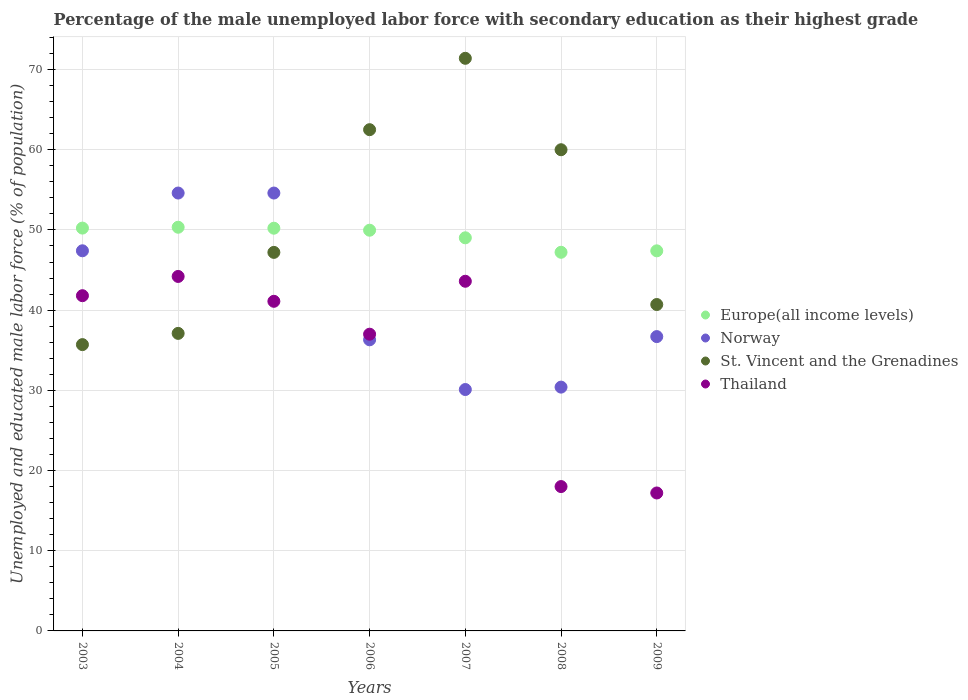What is the percentage of the unemployed male labor force with secondary education in St. Vincent and the Grenadines in 2009?
Make the answer very short. 40.7. Across all years, what is the maximum percentage of the unemployed male labor force with secondary education in Norway?
Your answer should be very brief. 54.6. Across all years, what is the minimum percentage of the unemployed male labor force with secondary education in Europe(all income levels)?
Provide a short and direct response. 47.21. In which year was the percentage of the unemployed male labor force with secondary education in Europe(all income levels) maximum?
Your answer should be very brief. 2004. What is the total percentage of the unemployed male labor force with secondary education in Thailand in the graph?
Offer a terse response. 242.9. What is the difference between the percentage of the unemployed male labor force with secondary education in Europe(all income levels) in 2007 and that in 2009?
Provide a short and direct response. 1.62. What is the difference between the percentage of the unemployed male labor force with secondary education in Europe(all income levels) in 2006 and the percentage of the unemployed male labor force with secondary education in Norway in 2005?
Your answer should be very brief. -4.63. What is the average percentage of the unemployed male labor force with secondary education in Norway per year?
Offer a terse response. 41.44. In the year 2003, what is the difference between the percentage of the unemployed male labor force with secondary education in Norway and percentage of the unemployed male labor force with secondary education in St. Vincent and the Grenadines?
Ensure brevity in your answer.  11.7. In how many years, is the percentage of the unemployed male labor force with secondary education in Europe(all income levels) greater than 34 %?
Provide a succinct answer. 7. What is the ratio of the percentage of the unemployed male labor force with secondary education in Europe(all income levels) in 2003 to that in 2004?
Provide a succinct answer. 1. Is the percentage of the unemployed male labor force with secondary education in Europe(all income levels) in 2003 less than that in 2009?
Offer a very short reply. No. Is the difference between the percentage of the unemployed male labor force with secondary education in Norway in 2007 and 2009 greater than the difference between the percentage of the unemployed male labor force with secondary education in St. Vincent and the Grenadines in 2007 and 2009?
Your response must be concise. No. What is the difference between the highest and the second highest percentage of the unemployed male labor force with secondary education in St. Vincent and the Grenadines?
Your response must be concise. 8.9. What is the difference between the highest and the lowest percentage of the unemployed male labor force with secondary education in St. Vincent and the Grenadines?
Make the answer very short. 35.7. Is it the case that in every year, the sum of the percentage of the unemployed male labor force with secondary education in Norway and percentage of the unemployed male labor force with secondary education in Europe(all income levels)  is greater than the sum of percentage of the unemployed male labor force with secondary education in Thailand and percentage of the unemployed male labor force with secondary education in St. Vincent and the Grenadines?
Offer a very short reply. No. Is it the case that in every year, the sum of the percentage of the unemployed male labor force with secondary education in Norway and percentage of the unemployed male labor force with secondary education in Thailand  is greater than the percentage of the unemployed male labor force with secondary education in Europe(all income levels)?
Ensure brevity in your answer.  Yes. Does the percentage of the unemployed male labor force with secondary education in Europe(all income levels) monotonically increase over the years?
Keep it short and to the point. No. Does the graph contain any zero values?
Give a very brief answer. No. Does the graph contain grids?
Your answer should be very brief. Yes. What is the title of the graph?
Offer a very short reply. Percentage of the male unemployed labor force with secondary education as their highest grade. What is the label or title of the X-axis?
Give a very brief answer. Years. What is the label or title of the Y-axis?
Offer a terse response. Unemployed and educated male labor force (% of population). What is the Unemployed and educated male labor force (% of population) of Europe(all income levels) in 2003?
Your answer should be very brief. 50.23. What is the Unemployed and educated male labor force (% of population) of Norway in 2003?
Your answer should be compact. 47.4. What is the Unemployed and educated male labor force (% of population) in St. Vincent and the Grenadines in 2003?
Make the answer very short. 35.7. What is the Unemployed and educated male labor force (% of population) in Thailand in 2003?
Keep it short and to the point. 41.8. What is the Unemployed and educated male labor force (% of population) of Europe(all income levels) in 2004?
Offer a very short reply. 50.34. What is the Unemployed and educated male labor force (% of population) in Norway in 2004?
Ensure brevity in your answer.  54.6. What is the Unemployed and educated male labor force (% of population) in St. Vincent and the Grenadines in 2004?
Give a very brief answer. 37.1. What is the Unemployed and educated male labor force (% of population) of Thailand in 2004?
Your answer should be compact. 44.2. What is the Unemployed and educated male labor force (% of population) in Europe(all income levels) in 2005?
Give a very brief answer. 50.22. What is the Unemployed and educated male labor force (% of population) in Norway in 2005?
Give a very brief answer. 54.6. What is the Unemployed and educated male labor force (% of population) in St. Vincent and the Grenadines in 2005?
Your answer should be very brief. 47.2. What is the Unemployed and educated male labor force (% of population) in Thailand in 2005?
Your answer should be very brief. 41.1. What is the Unemployed and educated male labor force (% of population) of Europe(all income levels) in 2006?
Give a very brief answer. 49.97. What is the Unemployed and educated male labor force (% of population) in Norway in 2006?
Offer a terse response. 36.3. What is the Unemployed and educated male labor force (% of population) of St. Vincent and the Grenadines in 2006?
Ensure brevity in your answer.  62.5. What is the Unemployed and educated male labor force (% of population) of Europe(all income levels) in 2007?
Provide a short and direct response. 49.02. What is the Unemployed and educated male labor force (% of population) in Norway in 2007?
Offer a very short reply. 30.1. What is the Unemployed and educated male labor force (% of population) in St. Vincent and the Grenadines in 2007?
Provide a short and direct response. 71.4. What is the Unemployed and educated male labor force (% of population) in Thailand in 2007?
Your answer should be compact. 43.6. What is the Unemployed and educated male labor force (% of population) of Europe(all income levels) in 2008?
Offer a very short reply. 47.21. What is the Unemployed and educated male labor force (% of population) of Norway in 2008?
Ensure brevity in your answer.  30.4. What is the Unemployed and educated male labor force (% of population) in Thailand in 2008?
Provide a succinct answer. 18. What is the Unemployed and educated male labor force (% of population) in Europe(all income levels) in 2009?
Your response must be concise. 47.39. What is the Unemployed and educated male labor force (% of population) in Norway in 2009?
Give a very brief answer. 36.7. What is the Unemployed and educated male labor force (% of population) in St. Vincent and the Grenadines in 2009?
Keep it short and to the point. 40.7. What is the Unemployed and educated male labor force (% of population) of Thailand in 2009?
Your response must be concise. 17.2. Across all years, what is the maximum Unemployed and educated male labor force (% of population) of Europe(all income levels)?
Your answer should be very brief. 50.34. Across all years, what is the maximum Unemployed and educated male labor force (% of population) in Norway?
Make the answer very short. 54.6. Across all years, what is the maximum Unemployed and educated male labor force (% of population) in St. Vincent and the Grenadines?
Offer a terse response. 71.4. Across all years, what is the maximum Unemployed and educated male labor force (% of population) in Thailand?
Provide a succinct answer. 44.2. Across all years, what is the minimum Unemployed and educated male labor force (% of population) of Europe(all income levels)?
Offer a very short reply. 47.21. Across all years, what is the minimum Unemployed and educated male labor force (% of population) of Norway?
Offer a terse response. 30.1. Across all years, what is the minimum Unemployed and educated male labor force (% of population) of St. Vincent and the Grenadines?
Your response must be concise. 35.7. Across all years, what is the minimum Unemployed and educated male labor force (% of population) of Thailand?
Offer a terse response. 17.2. What is the total Unemployed and educated male labor force (% of population) in Europe(all income levels) in the graph?
Your response must be concise. 344.37. What is the total Unemployed and educated male labor force (% of population) of Norway in the graph?
Provide a short and direct response. 290.1. What is the total Unemployed and educated male labor force (% of population) of St. Vincent and the Grenadines in the graph?
Give a very brief answer. 354.6. What is the total Unemployed and educated male labor force (% of population) of Thailand in the graph?
Provide a short and direct response. 242.9. What is the difference between the Unemployed and educated male labor force (% of population) of Europe(all income levels) in 2003 and that in 2004?
Offer a very short reply. -0.11. What is the difference between the Unemployed and educated male labor force (% of population) of St. Vincent and the Grenadines in 2003 and that in 2004?
Offer a terse response. -1.4. What is the difference between the Unemployed and educated male labor force (% of population) in Europe(all income levels) in 2003 and that in 2005?
Give a very brief answer. 0.01. What is the difference between the Unemployed and educated male labor force (% of population) of St. Vincent and the Grenadines in 2003 and that in 2005?
Make the answer very short. -11.5. What is the difference between the Unemployed and educated male labor force (% of population) in Europe(all income levels) in 2003 and that in 2006?
Your answer should be very brief. 0.26. What is the difference between the Unemployed and educated male labor force (% of population) of Norway in 2003 and that in 2006?
Ensure brevity in your answer.  11.1. What is the difference between the Unemployed and educated male labor force (% of population) of St. Vincent and the Grenadines in 2003 and that in 2006?
Offer a terse response. -26.8. What is the difference between the Unemployed and educated male labor force (% of population) of Europe(all income levels) in 2003 and that in 2007?
Your answer should be compact. 1.21. What is the difference between the Unemployed and educated male labor force (% of population) in St. Vincent and the Grenadines in 2003 and that in 2007?
Give a very brief answer. -35.7. What is the difference between the Unemployed and educated male labor force (% of population) in Thailand in 2003 and that in 2007?
Keep it short and to the point. -1.8. What is the difference between the Unemployed and educated male labor force (% of population) in Europe(all income levels) in 2003 and that in 2008?
Ensure brevity in your answer.  3.02. What is the difference between the Unemployed and educated male labor force (% of population) in Norway in 2003 and that in 2008?
Offer a terse response. 17. What is the difference between the Unemployed and educated male labor force (% of population) in St. Vincent and the Grenadines in 2003 and that in 2008?
Make the answer very short. -24.3. What is the difference between the Unemployed and educated male labor force (% of population) of Thailand in 2003 and that in 2008?
Your answer should be very brief. 23.8. What is the difference between the Unemployed and educated male labor force (% of population) in Europe(all income levels) in 2003 and that in 2009?
Provide a short and direct response. 2.84. What is the difference between the Unemployed and educated male labor force (% of population) in St. Vincent and the Grenadines in 2003 and that in 2009?
Ensure brevity in your answer.  -5. What is the difference between the Unemployed and educated male labor force (% of population) of Thailand in 2003 and that in 2009?
Make the answer very short. 24.6. What is the difference between the Unemployed and educated male labor force (% of population) in Europe(all income levels) in 2004 and that in 2005?
Keep it short and to the point. 0.12. What is the difference between the Unemployed and educated male labor force (% of population) in St. Vincent and the Grenadines in 2004 and that in 2005?
Make the answer very short. -10.1. What is the difference between the Unemployed and educated male labor force (% of population) of Thailand in 2004 and that in 2005?
Make the answer very short. 3.1. What is the difference between the Unemployed and educated male labor force (% of population) in Europe(all income levels) in 2004 and that in 2006?
Offer a very short reply. 0.37. What is the difference between the Unemployed and educated male labor force (% of population) in Norway in 2004 and that in 2006?
Provide a short and direct response. 18.3. What is the difference between the Unemployed and educated male labor force (% of population) in St. Vincent and the Grenadines in 2004 and that in 2006?
Provide a succinct answer. -25.4. What is the difference between the Unemployed and educated male labor force (% of population) in Thailand in 2004 and that in 2006?
Provide a short and direct response. 7.2. What is the difference between the Unemployed and educated male labor force (% of population) of Europe(all income levels) in 2004 and that in 2007?
Give a very brief answer. 1.32. What is the difference between the Unemployed and educated male labor force (% of population) in St. Vincent and the Grenadines in 2004 and that in 2007?
Your answer should be very brief. -34.3. What is the difference between the Unemployed and educated male labor force (% of population) of Thailand in 2004 and that in 2007?
Offer a very short reply. 0.6. What is the difference between the Unemployed and educated male labor force (% of population) in Europe(all income levels) in 2004 and that in 2008?
Offer a very short reply. 3.12. What is the difference between the Unemployed and educated male labor force (% of population) in Norway in 2004 and that in 2008?
Make the answer very short. 24.2. What is the difference between the Unemployed and educated male labor force (% of population) of St. Vincent and the Grenadines in 2004 and that in 2008?
Provide a succinct answer. -22.9. What is the difference between the Unemployed and educated male labor force (% of population) of Thailand in 2004 and that in 2008?
Offer a terse response. 26.2. What is the difference between the Unemployed and educated male labor force (% of population) in Europe(all income levels) in 2004 and that in 2009?
Your answer should be compact. 2.94. What is the difference between the Unemployed and educated male labor force (% of population) of Norway in 2004 and that in 2009?
Ensure brevity in your answer.  17.9. What is the difference between the Unemployed and educated male labor force (% of population) of Europe(all income levels) in 2005 and that in 2006?
Your answer should be very brief. 0.25. What is the difference between the Unemployed and educated male labor force (% of population) in Norway in 2005 and that in 2006?
Your answer should be compact. 18.3. What is the difference between the Unemployed and educated male labor force (% of population) of St. Vincent and the Grenadines in 2005 and that in 2006?
Offer a very short reply. -15.3. What is the difference between the Unemployed and educated male labor force (% of population) in Europe(all income levels) in 2005 and that in 2007?
Your answer should be very brief. 1.2. What is the difference between the Unemployed and educated male labor force (% of population) in Norway in 2005 and that in 2007?
Provide a short and direct response. 24.5. What is the difference between the Unemployed and educated male labor force (% of population) in St. Vincent and the Grenadines in 2005 and that in 2007?
Your answer should be compact. -24.2. What is the difference between the Unemployed and educated male labor force (% of population) of Thailand in 2005 and that in 2007?
Your response must be concise. -2.5. What is the difference between the Unemployed and educated male labor force (% of population) of Europe(all income levels) in 2005 and that in 2008?
Keep it short and to the point. 3. What is the difference between the Unemployed and educated male labor force (% of population) in Norway in 2005 and that in 2008?
Give a very brief answer. 24.2. What is the difference between the Unemployed and educated male labor force (% of population) of St. Vincent and the Grenadines in 2005 and that in 2008?
Keep it short and to the point. -12.8. What is the difference between the Unemployed and educated male labor force (% of population) in Thailand in 2005 and that in 2008?
Your answer should be very brief. 23.1. What is the difference between the Unemployed and educated male labor force (% of population) of Europe(all income levels) in 2005 and that in 2009?
Ensure brevity in your answer.  2.82. What is the difference between the Unemployed and educated male labor force (% of population) of Thailand in 2005 and that in 2009?
Give a very brief answer. 23.9. What is the difference between the Unemployed and educated male labor force (% of population) of Europe(all income levels) in 2006 and that in 2007?
Provide a short and direct response. 0.95. What is the difference between the Unemployed and educated male labor force (% of population) in Europe(all income levels) in 2006 and that in 2008?
Your response must be concise. 2.75. What is the difference between the Unemployed and educated male labor force (% of population) of Norway in 2006 and that in 2008?
Offer a terse response. 5.9. What is the difference between the Unemployed and educated male labor force (% of population) in St. Vincent and the Grenadines in 2006 and that in 2008?
Your response must be concise. 2.5. What is the difference between the Unemployed and educated male labor force (% of population) in Thailand in 2006 and that in 2008?
Give a very brief answer. 19. What is the difference between the Unemployed and educated male labor force (% of population) of Europe(all income levels) in 2006 and that in 2009?
Your response must be concise. 2.57. What is the difference between the Unemployed and educated male labor force (% of population) of Norway in 2006 and that in 2009?
Ensure brevity in your answer.  -0.4. What is the difference between the Unemployed and educated male labor force (% of population) in St. Vincent and the Grenadines in 2006 and that in 2009?
Your answer should be very brief. 21.8. What is the difference between the Unemployed and educated male labor force (% of population) in Thailand in 2006 and that in 2009?
Provide a succinct answer. 19.8. What is the difference between the Unemployed and educated male labor force (% of population) in Europe(all income levels) in 2007 and that in 2008?
Your answer should be very brief. 1.8. What is the difference between the Unemployed and educated male labor force (% of population) of Thailand in 2007 and that in 2008?
Your response must be concise. 25.6. What is the difference between the Unemployed and educated male labor force (% of population) of Europe(all income levels) in 2007 and that in 2009?
Offer a terse response. 1.62. What is the difference between the Unemployed and educated male labor force (% of population) in St. Vincent and the Grenadines in 2007 and that in 2009?
Offer a very short reply. 30.7. What is the difference between the Unemployed and educated male labor force (% of population) of Thailand in 2007 and that in 2009?
Offer a terse response. 26.4. What is the difference between the Unemployed and educated male labor force (% of population) of Europe(all income levels) in 2008 and that in 2009?
Make the answer very short. -0.18. What is the difference between the Unemployed and educated male labor force (% of population) in Norway in 2008 and that in 2009?
Offer a terse response. -6.3. What is the difference between the Unemployed and educated male labor force (% of population) of St. Vincent and the Grenadines in 2008 and that in 2009?
Your answer should be very brief. 19.3. What is the difference between the Unemployed and educated male labor force (% of population) in Europe(all income levels) in 2003 and the Unemployed and educated male labor force (% of population) in Norway in 2004?
Ensure brevity in your answer.  -4.37. What is the difference between the Unemployed and educated male labor force (% of population) in Europe(all income levels) in 2003 and the Unemployed and educated male labor force (% of population) in St. Vincent and the Grenadines in 2004?
Make the answer very short. 13.13. What is the difference between the Unemployed and educated male labor force (% of population) in Europe(all income levels) in 2003 and the Unemployed and educated male labor force (% of population) in Thailand in 2004?
Make the answer very short. 6.03. What is the difference between the Unemployed and educated male labor force (% of population) of Europe(all income levels) in 2003 and the Unemployed and educated male labor force (% of population) of Norway in 2005?
Your answer should be compact. -4.37. What is the difference between the Unemployed and educated male labor force (% of population) in Europe(all income levels) in 2003 and the Unemployed and educated male labor force (% of population) in St. Vincent and the Grenadines in 2005?
Ensure brevity in your answer.  3.03. What is the difference between the Unemployed and educated male labor force (% of population) of Europe(all income levels) in 2003 and the Unemployed and educated male labor force (% of population) of Thailand in 2005?
Your response must be concise. 9.13. What is the difference between the Unemployed and educated male labor force (% of population) of Europe(all income levels) in 2003 and the Unemployed and educated male labor force (% of population) of Norway in 2006?
Your response must be concise. 13.93. What is the difference between the Unemployed and educated male labor force (% of population) of Europe(all income levels) in 2003 and the Unemployed and educated male labor force (% of population) of St. Vincent and the Grenadines in 2006?
Make the answer very short. -12.27. What is the difference between the Unemployed and educated male labor force (% of population) in Europe(all income levels) in 2003 and the Unemployed and educated male labor force (% of population) in Thailand in 2006?
Provide a succinct answer. 13.23. What is the difference between the Unemployed and educated male labor force (% of population) of Norway in 2003 and the Unemployed and educated male labor force (% of population) of St. Vincent and the Grenadines in 2006?
Ensure brevity in your answer.  -15.1. What is the difference between the Unemployed and educated male labor force (% of population) in Europe(all income levels) in 2003 and the Unemployed and educated male labor force (% of population) in Norway in 2007?
Give a very brief answer. 20.13. What is the difference between the Unemployed and educated male labor force (% of population) in Europe(all income levels) in 2003 and the Unemployed and educated male labor force (% of population) in St. Vincent and the Grenadines in 2007?
Provide a short and direct response. -21.17. What is the difference between the Unemployed and educated male labor force (% of population) in Europe(all income levels) in 2003 and the Unemployed and educated male labor force (% of population) in Thailand in 2007?
Your answer should be very brief. 6.63. What is the difference between the Unemployed and educated male labor force (% of population) of St. Vincent and the Grenadines in 2003 and the Unemployed and educated male labor force (% of population) of Thailand in 2007?
Your answer should be compact. -7.9. What is the difference between the Unemployed and educated male labor force (% of population) in Europe(all income levels) in 2003 and the Unemployed and educated male labor force (% of population) in Norway in 2008?
Your answer should be very brief. 19.83. What is the difference between the Unemployed and educated male labor force (% of population) of Europe(all income levels) in 2003 and the Unemployed and educated male labor force (% of population) of St. Vincent and the Grenadines in 2008?
Your response must be concise. -9.77. What is the difference between the Unemployed and educated male labor force (% of population) in Europe(all income levels) in 2003 and the Unemployed and educated male labor force (% of population) in Thailand in 2008?
Make the answer very short. 32.23. What is the difference between the Unemployed and educated male labor force (% of population) in Norway in 2003 and the Unemployed and educated male labor force (% of population) in St. Vincent and the Grenadines in 2008?
Provide a succinct answer. -12.6. What is the difference between the Unemployed and educated male labor force (% of population) in Norway in 2003 and the Unemployed and educated male labor force (% of population) in Thailand in 2008?
Your answer should be very brief. 29.4. What is the difference between the Unemployed and educated male labor force (% of population) of Europe(all income levels) in 2003 and the Unemployed and educated male labor force (% of population) of Norway in 2009?
Your answer should be very brief. 13.53. What is the difference between the Unemployed and educated male labor force (% of population) of Europe(all income levels) in 2003 and the Unemployed and educated male labor force (% of population) of St. Vincent and the Grenadines in 2009?
Offer a very short reply. 9.53. What is the difference between the Unemployed and educated male labor force (% of population) of Europe(all income levels) in 2003 and the Unemployed and educated male labor force (% of population) of Thailand in 2009?
Offer a terse response. 33.03. What is the difference between the Unemployed and educated male labor force (% of population) in Norway in 2003 and the Unemployed and educated male labor force (% of population) in Thailand in 2009?
Keep it short and to the point. 30.2. What is the difference between the Unemployed and educated male labor force (% of population) of Europe(all income levels) in 2004 and the Unemployed and educated male labor force (% of population) of Norway in 2005?
Give a very brief answer. -4.26. What is the difference between the Unemployed and educated male labor force (% of population) of Europe(all income levels) in 2004 and the Unemployed and educated male labor force (% of population) of St. Vincent and the Grenadines in 2005?
Make the answer very short. 3.14. What is the difference between the Unemployed and educated male labor force (% of population) of Europe(all income levels) in 2004 and the Unemployed and educated male labor force (% of population) of Thailand in 2005?
Provide a succinct answer. 9.24. What is the difference between the Unemployed and educated male labor force (% of population) in Europe(all income levels) in 2004 and the Unemployed and educated male labor force (% of population) in Norway in 2006?
Your answer should be very brief. 14.04. What is the difference between the Unemployed and educated male labor force (% of population) of Europe(all income levels) in 2004 and the Unemployed and educated male labor force (% of population) of St. Vincent and the Grenadines in 2006?
Ensure brevity in your answer.  -12.16. What is the difference between the Unemployed and educated male labor force (% of population) in Europe(all income levels) in 2004 and the Unemployed and educated male labor force (% of population) in Thailand in 2006?
Offer a terse response. 13.34. What is the difference between the Unemployed and educated male labor force (% of population) in Norway in 2004 and the Unemployed and educated male labor force (% of population) in Thailand in 2006?
Keep it short and to the point. 17.6. What is the difference between the Unemployed and educated male labor force (% of population) of Europe(all income levels) in 2004 and the Unemployed and educated male labor force (% of population) of Norway in 2007?
Provide a short and direct response. 20.24. What is the difference between the Unemployed and educated male labor force (% of population) in Europe(all income levels) in 2004 and the Unemployed and educated male labor force (% of population) in St. Vincent and the Grenadines in 2007?
Offer a terse response. -21.06. What is the difference between the Unemployed and educated male labor force (% of population) of Europe(all income levels) in 2004 and the Unemployed and educated male labor force (% of population) of Thailand in 2007?
Your answer should be compact. 6.74. What is the difference between the Unemployed and educated male labor force (% of population) in Norway in 2004 and the Unemployed and educated male labor force (% of population) in St. Vincent and the Grenadines in 2007?
Ensure brevity in your answer.  -16.8. What is the difference between the Unemployed and educated male labor force (% of population) of St. Vincent and the Grenadines in 2004 and the Unemployed and educated male labor force (% of population) of Thailand in 2007?
Give a very brief answer. -6.5. What is the difference between the Unemployed and educated male labor force (% of population) in Europe(all income levels) in 2004 and the Unemployed and educated male labor force (% of population) in Norway in 2008?
Offer a terse response. 19.94. What is the difference between the Unemployed and educated male labor force (% of population) in Europe(all income levels) in 2004 and the Unemployed and educated male labor force (% of population) in St. Vincent and the Grenadines in 2008?
Give a very brief answer. -9.66. What is the difference between the Unemployed and educated male labor force (% of population) in Europe(all income levels) in 2004 and the Unemployed and educated male labor force (% of population) in Thailand in 2008?
Ensure brevity in your answer.  32.34. What is the difference between the Unemployed and educated male labor force (% of population) in Norway in 2004 and the Unemployed and educated male labor force (% of population) in Thailand in 2008?
Make the answer very short. 36.6. What is the difference between the Unemployed and educated male labor force (% of population) in Europe(all income levels) in 2004 and the Unemployed and educated male labor force (% of population) in Norway in 2009?
Ensure brevity in your answer.  13.64. What is the difference between the Unemployed and educated male labor force (% of population) in Europe(all income levels) in 2004 and the Unemployed and educated male labor force (% of population) in St. Vincent and the Grenadines in 2009?
Make the answer very short. 9.64. What is the difference between the Unemployed and educated male labor force (% of population) in Europe(all income levels) in 2004 and the Unemployed and educated male labor force (% of population) in Thailand in 2009?
Your answer should be very brief. 33.14. What is the difference between the Unemployed and educated male labor force (% of population) in Norway in 2004 and the Unemployed and educated male labor force (% of population) in Thailand in 2009?
Provide a short and direct response. 37.4. What is the difference between the Unemployed and educated male labor force (% of population) in Europe(all income levels) in 2005 and the Unemployed and educated male labor force (% of population) in Norway in 2006?
Keep it short and to the point. 13.92. What is the difference between the Unemployed and educated male labor force (% of population) of Europe(all income levels) in 2005 and the Unemployed and educated male labor force (% of population) of St. Vincent and the Grenadines in 2006?
Offer a terse response. -12.28. What is the difference between the Unemployed and educated male labor force (% of population) of Europe(all income levels) in 2005 and the Unemployed and educated male labor force (% of population) of Thailand in 2006?
Your response must be concise. 13.22. What is the difference between the Unemployed and educated male labor force (% of population) of St. Vincent and the Grenadines in 2005 and the Unemployed and educated male labor force (% of population) of Thailand in 2006?
Ensure brevity in your answer.  10.2. What is the difference between the Unemployed and educated male labor force (% of population) in Europe(all income levels) in 2005 and the Unemployed and educated male labor force (% of population) in Norway in 2007?
Make the answer very short. 20.12. What is the difference between the Unemployed and educated male labor force (% of population) of Europe(all income levels) in 2005 and the Unemployed and educated male labor force (% of population) of St. Vincent and the Grenadines in 2007?
Provide a short and direct response. -21.18. What is the difference between the Unemployed and educated male labor force (% of population) in Europe(all income levels) in 2005 and the Unemployed and educated male labor force (% of population) in Thailand in 2007?
Provide a short and direct response. 6.62. What is the difference between the Unemployed and educated male labor force (% of population) of Norway in 2005 and the Unemployed and educated male labor force (% of population) of St. Vincent and the Grenadines in 2007?
Your response must be concise. -16.8. What is the difference between the Unemployed and educated male labor force (% of population) in Norway in 2005 and the Unemployed and educated male labor force (% of population) in Thailand in 2007?
Make the answer very short. 11. What is the difference between the Unemployed and educated male labor force (% of population) of Europe(all income levels) in 2005 and the Unemployed and educated male labor force (% of population) of Norway in 2008?
Offer a terse response. 19.82. What is the difference between the Unemployed and educated male labor force (% of population) of Europe(all income levels) in 2005 and the Unemployed and educated male labor force (% of population) of St. Vincent and the Grenadines in 2008?
Make the answer very short. -9.78. What is the difference between the Unemployed and educated male labor force (% of population) in Europe(all income levels) in 2005 and the Unemployed and educated male labor force (% of population) in Thailand in 2008?
Your answer should be compact. 32.22. What is the difference between the Unemployed and educated male labor force (% of population) of Norway in 2005 and the Unemployed and educated male labor force (% of population) of Thailand in 2008?
Provide a succinct answer. 36.6. What is the difference between the Unemployed and educated male labor force (% of population) of St. Vincent and the Grenadines in 2005 and the Unemployed and educated male labor force (% of population) of Thailand in 2008?
Your answer should be compact. 29.2. What is the difference between the Unemployed and educated male labor force (% of population) in Europe(all income levels) in 2005 and the Unemployed and educated male labor force (% of population) in Norway in 2009?
Offer a very short reply. 13.52. What is the difference between the Unemployed and educated male labor force (% of population) in Europe(all income levels) in 2005 and the Unemployed and educated male labor force (% of population) in St. Vincent and the Grenadines in 2009?
Your response must be concise. 9.52. What is the difference between the Unemployed and educated male labor force (% of population) in Europe(all income levels) in 2005 and the Unemployed and educated male labor force (% of population) in Thailand in 2009?
Provide a succinct answer. 33.02. What is the difference between the Unemployed and educated male labor force (% of population) of Norway in 2005 and the Unemployed and educated male labor force (% of population) of Thailand in 2009?
Offer a terse response. 37.4. What is the difference between the Unemployed and educated male labor force (% of population) of St. Vincent and the Grenadines in 2005 and the Unemployed and educated male labor force (% of population) of Thailand in 2009?
Give a very brief answer. 30. What is the difference between the Unemployed and educated male labor force (% of population) in Europe(all income levels) in 2006 and the Unemployed and educated male labor force (% of population) in Norway in 2007?
Your answer should be compact. 19.87. What is the difference between the Unemployed and educated male labor force (% of population) in Europe(all income levels) in 2006 and the Unemployed and educated male labor force (% of population) in St. Vincent and the Grenadines in 2007?
Keep it short and to the point. -21.43. What is the difference between the Unemployed and educated male labor force (% of population) in Europe(all income levels) in 2006 and the Unemployed and educated male labor force (% of population) in Thailand in 2007?
Your response must be concise. 6.37. What is the difference between the Unemployed and educated male labor force (% of population) in Norway in 2006 and the Unemployed and educated male labor force (% of population) in St. Vincent and the Grenadines in 2007?
Your answer should be compact. -35.1. What is the difference between the Unemployed and educated male labor force (% of population) of Norway in 2006 and the Unemployed and educated male labor force (% of population) of Thailand in 2007?
Ensure brevity in your answer.  -7.3. What is the difference between the Unemployed and educated male labor force (% of population) of St. Vincent and the Grenadines in 2006 and the Unemployed and educated male labor force (% of population) of Thailand in 2007?
Ensure brevity in your answer.  18.9. What is the difference between the Unemployed and educated male labor force (% of population) in Europe(all income levels) in 2006 and the Unemployed and educated male labor force (% of population) in Norway in 2008?
Give a very brief answer. 19.57. What is the difference between the Unemployed and educated male labor force (% of population) of Europe(all income levels) in 2006 and the Unemployed and educated male labor force (% of population) of St. Vincent and the Grenadines in 2008?
Your response must be concise. -10.03. What is the difference between the Unemployed and educated male labor force (% of population) of Europe(all income levels) in 2006 and the Unemployed and educated male labor force (% of population) of Thailand in 2008?
Keep it short and to the point. 31.97. What is the difference between the Unemployed and educated male labor force (% of population) in Norway in 2006 and the Unemployed and educated male labor force (% of population) in St. Vincent and the Grenadines in 2008?
Make the answer very short. -23.7. What is the difference between the Unemployed and educated male labor force (% of population) in Norway in 2006 and the Unemployed and educated male labor force (% of population) in Thailand in 2008?
Provide a short and direct response. 18.3. What is the difference between the Unemployed and educated male labor force (% of population) in St. Vincent and the Grenadines in 2006 and the Unemployed and educated male labor force (% of population) in Thailand in 2008?
Give a very brief answer. 44.5. What is the difference between the Unemployed and educated male labor force (% of population) of Europe(all income levels) in 2006 and the Unemployed and educated male labor force (% of population) of Norway in 2009?
Ensure brevity in your answer.  13.27. What is the difference between the Unemployed and educated male labor force (% of population) in Europe(all income levels) in 2006 and the Unemployed and educated male labor force (% of population) in St. Vincent and the Grenadines in 2009?
Keep it short and to the point. 9.27. What is the difference between the Unemployed and educated male labor force (% of population) of Europe(all income levels) in 2006 and the Unemployed and educated male labor force (% of population) of Thailand in 2009?
Provide a succinct answer. 32.77. What is the difference between the Unemployed and educated male labor force (% of population) of Norway in 2006 and the Unemployed and educated male labor force (% of population) of Thailand in 2009?
Your answer should be compact. 19.1. What is the difference between the Unemployed and educated male labor force (% of population) of St. Vincent and the Grenadines in 2006 and the Unemployed and educated male labor force (% of population) of Thailand in 2009?
Your response must be concise. 45.3. What is the difference between the Unemployed and educated male labor force (% of population) in Europe(all income levels) in 2007 and the Unemployed and educated male labor force (% of population) in Norway in 2008?
Offer a very short reply. 18.62. What is the difference between the Unemployed and educated male labor force (% of population) of Europe(all income levels) in 2007 and the Unemployed and educated male labor force (% of population) of St. Vincent and the Grenadines in 2008?
Provide a short and direct response. -10.98. What is the difference between the Unemployed and educated male labor force (% of population) in Europe(all income levels) in 2007 and the Unemployed and educated male labor force (% of population) in Thailand in 2008?
Your response must be concise. 31.02. What is the difference between the Unemployed and educated male labor force (% of population) of Norway in 2007 and the Unemployed and educated male labor force (% of population) of St. Vincent and the Grenadines in 2008?
Make the answer very short. -29.9. What is the difference between the Unemployed and educated male labor force (% of population) of Norway in 2007 and the Unemployed and educated male labor force (% of population) of Thailand in 2008?
Offer a terse response. 12.1. What is the difference between the Unemployed and educated male labor force (% of population) of St. Vincent and the Grenadines in 2007 and the Unemployed and educated male labor force (% of population) of Thailand in 2008?
Make the answer very short. 53.4. What is the difference between the Unemployed and educated male labor force (% of population) of Europe(all income levels) in 2007 and the Unemployed and educated male labor force (% of population) of Norway in 2009?
Your answer should be compact. 12.32. What is the difference between the Unemployed and educated male labor force (% of population) of Europe(all income levels) in 2007 and the Unemployed and educated male labor force (% of population) of St. Vincent and the Grenadines in 2009?
Your answer should be compact. 8.32. What is the difference between the Unemployed and educated male labor force (% of population) of Europe(all income levels) in 2007 and the Unemployed and educated male labor force (% of population) of Thailand in 2009?
Give a very brief answer. 31.82. What is the difference between the Unemployed and educated male labor force (% of population) in Norway in 2007 and the Unemployed and educated male labor force (% of population) in St. Vincent and the Grenadines in 2009?
Your answer should be compact. -10.6. What is the difference between the Unemployed and educated male labor force (% of population) of St. Vincent and the Grenadines in 2007 and the Unemployed and educated male labor force (% of population) of Thailand in 2009?
Give a very brief answer. 54.2. What is the difference between the Unemployed and educated male labor force (% of population) in Europe(all income levels) in 2008 and the Unemployed and educated male labor force (% of population) in Norway in 2009?
Give a very brief answer. 10.51. What is the difference between the Unemployed and educated male labor force (% of population) in Europe(all income levels) in 2008 and the Unemployed and educated male labor force (% of population) in St. Vincent and the Grenadines in 2009?
Keep it short and to the point. 6.51. What is the difference between the Unemployed and educated male labor force (% of population) of Europe(all income levels) in 2008 and the Unemployed and educated male labor force (% of population) of Thailand in 2009?
Your answer should be compact. 30.01. What is the difference between the Unemployed and educated male labor force (% of population) of St. Vincent and the Grenadines in 2008 and the Unemployed and educated male labor force (% of population) of Thailand in 2009?
Offer a very short reply. 42.8. What is the average Unemployed and educated male labor force (% of population) in Europe(all income levels) per year?
Your response must be concise. 49.2. What is the average Unemployed and educated male labor force (% of population) in Norway per year?
Give a very brief answer. 41.44. What is the average Unemployed and educated male labor force (% of population) in St. Vincent and the Grenadines per year?
Offer a very short reply. 50.66. What is the average Unemployed and educated male labor force (% of population) of Thailand per year?
Provide a short and direct response. 34.7. In the year 2003, what is the difference between the Unemployed and educated male labor force (% of population) in Europe(all income levels) and Unemployed and educated male labor force (% of population) in Norway?
Ensure brevity in your answer.  2.83. In the year 2003, what is the difference between the Unemployed and educated male labor force (% of population) in Europe(all income levels) and Unemployed and educated male labor force (% of population) in St. Vincent and the Grenadines?
Keep it short and to the point. 14.53. In the year 2003, what is the difference between the Unemployed and educated male labor force (% of population) in Europe(all income levels) and Unemployed and educated male labor force (% of population) in Thailand?
Provide a short and direct response. 8.43. In the year 2003, what is the difference between the Unemployed and educated male labor force (% of population) of Norway and Unemployed and educated male labor force (% of population) of St. Vincent and the Grenadines?
Your answer should be very brief. 11.7. In the year 2003, what is the difference between the Unemployed and educated male labor force (% of population) in St. Vincent and the Grenadines and Unemployed and educated male labor force (% of population) in Thailand?
Ensure brevity in your answer.  -6.1. In the year 2004, what is the difference between the Unemployed and educated male labor force (% of population) of Europe(all income levels) and Unemployed and educated male labor force (% of population) of Norway?
Give a very brief answer. -4.26. In the year 2004, what is the difference between the Unemployed and educated male labor force (% of population) of Europe(all income levels) and Unemployed and educated male labor force (% of population) of St. Vincent and the Grenadines?
Offer a terse response. 13.24. In the year 2004, what is the difference between the Unemployed and educated male labor force (% of population) of Europe(all income levels) and Unemployed and educated male labor force (% of population) of Thailand?
Your response must be concise. 6.14. In the year 2004, what is the difference between the Unemployed and educated male labor force (% of population) of Norway and Unemployed and educated male labor force (% of population) of Thailand?
Ensure brevity in your answer.  10.4. In the year 2005, what is the difference between the Unemployed and educated male labor force (% of population) in Europe(all income levels) and Unemployed and educated male labor force (% of population) in Norway?
Ensure brevity in your answer.  -4.38. In the year 2005, what is the difference between the Unemployed and educated male labor force (% of population) of Europe(all income levels) and Unemployed and educated male labor force (% of population) of St. Vincent and the Grenadines?
Ensure brevity in your answer.  3.02. In the year 2005, what is the difference between the Unemployed and educated male labor force (% of population) of Europe(all income levels) and Unemployed and educated male labor force (% of population) of Thailand?
Provide a short and direct response. 9.12. In the year 2005, what is the difference between the Unemployed and educated male labor force (% of population) in Norway and Unemployed and educated male labor force (% of population) in St. Vincent and the Grenadines?
Offer a terse response. 7.4. In the year 2005, what is the difference between the Unemployed and educated male labor force (% of population) in St. Vincent and the Grenadines and Unemployed and educated male labor force (% of population) in Thailand?
Your answer should be compact. 6.1. In the year 2006, what is the difference between the Unemployed and educated male labor force (% of population) of Europe(all income levels) and Unemployed and educated male labor force (% of population) of Norway?
Provide a succinct answer. 13.67. In the year 2006, what is the difference between the Unemployed and educated male labor force (% of population) in Europe(all income levels) and Unemployed and educated male labor force (% of population) in St. Vincent and the Grenadines?
Your response must be concise. -12.53. In the year 2006, what is the difference between the Unemployed and educated male labor force (% of population) in Europe(all income levels) and Unemployed and educated male labor force (% of population) in Thailand?
Give a very brief answer. 12.97. In the year 2006, what is the difference between the Unemployed and educated male labor force (% of population) of Norway and Unemployed and educated male labor force (% of population) of St. Vincent and the Grenadines?
Keep it short and to the point. -26.2. In the year 2006, what is the difference between the Unemployed and educated male labor force (% of population) in Norway and Unemployed and educated male labor force (% of population) in Thailand?
Give a very brief answer. -0.7. In the year 2006, what is the difference between the Unemployed and educated male labor force (% of population) in St. Vincent and the Grenadines and Unemployed and educated male labor force (% of population) in Thailand?
Your response must be concise. 25.5. In the year 2007, what is the difference between the Unemployed and educated male labor force (% of population) of Europe(all income levels) and Unemployed and educated male labor force (% of population) of Norway?
Your answer should be very brief. 18.92. In the year 2007, what is the difference between the Unemployed and educated male labor force (% of population) of Europe(all income levels) and Unemployed and educated male labor force (% of population) of St. Vincent and the Grenadines?
Offer a terse response. -22.38. In the year 2007, what is the difference between the Unemployed and educated male labor force (% of population) in Europe(all income levels) and Unemployed and educated male labor force (% of population) in Thailand?
Your answer should be compact. 5.42. In the year 2007, what is the difference between the Unemployed and educated male labor force (% of population) in Norway and Unemployed and educated male labor force (% of population) in St. Vincent and the Grenadines?
Your answer should be compact. -41.3. In the year 2007, what is the difference between the Unemployed and educated male labor force (% of population) of Norway and Unemployed and educated male labor force (% of population) of Thailand?
Make the answer very short. -13.5. In the year 2007, what is the difference between the Unemployed and educated male labor force (% of population) of St. Vincent and the Grenadines and Unemployed and educated male labor force (% of population) of Thailand?
Make the answer very short. 27.8. In the year 2008, what is the difference between the Unemployed and educated male labor force (% of population) in Europe(all income levels) and Unemployed and educated male labor force (% of population) in Norway?
Provide a short and direct response. 16.81. In the year 2008, what is the difference between the Unemployed and educated male labor force (% of population) of Europe(all income levels) and Unemployed and educated male labor force (% of population) of St. Vincent and the Grenadines?
Ensure brevity in your answer.  -12.79. In the year 2008, what is the difference between the Unemployed and educated male labor force (% of population) of Europe(all income levels) and Unemployed and educated male labor force (% of population) of Thailand?
Your answer should be compact. 29.21. In the year 2008, what is the difference between the Unemployed and educated male labor force (% of population) in Norway and Unemployed and educated male labor force (% of population) in St. Vincent and the Grenadines?
Keep it short and to the point. -29.6. In the year 2008, what is the difference between the Unemployed and educated male labor force (% of population) of Norway and Unemployed and educated male labor force (% of population) of Thailand?
Offer a terse response. 12.4. In the year 2008, what is the difference between the Unemployed and educated male labor force (% of population) in St. Vincent and the Grenadines and Unemployed and educated male labor force (% of population) in Thailand?
Offer a terse response. 42. In the year 2009, what is the difference between the Unemployed and educated male labor force (% of population) in Europe(all income levels) and Unemployed and educated male labor force (% of population) in Norway?
Give a very brief answer. 10.69. In the year 2009, what is the difference between the Unemployed and educated male labor force (% of population) in Europe(all income levels) and Unemployed and educated male labor force (% of population) in St. Vincent and the Grenadines?
Offer a very short reply. 6.69. In the year 2009, what is the difference between the Unemployed and educated male labor force (% of population) of Europe(all income levels) and Unemployed and educated male labor force (% of population) of Thailand?
Offer a very short reply. 30.19. What is the ratio of the Unemployed and educated male labor force (% of population) in Europe(all income levels) in 2003 to that in 2004?
Make the answer very short. 1. What is the ratio of the Unemployed and educated male labor force (% of population) of Norway in 2003 to that in 2004?
Offer a terse response. 0.87. What is the ratio of the Unemployed and educated male labor force (% of population) of St. Vincent and the Grenadines in 2003 to that in 2004?
Make the answer very short. 0.96. What is the ratio of the Unemployed and educated male labor force (% of population) of Thailand in 2003 to that in 2004?
Provide a short and direct response. 0.95. What is the ratio of the Unemployed and educated male labor force (% of population) in Europe(all income levels) in 2003 to that in 2005?
Ensure brevity in your answer.  1. What is the ratio of the Unemployed and educated male labor force (% of population) of Norway in 2003 to that in 2005?
Keep it short and to the point. 0.87. What is the ratio of the Unemployed and educated male labor force (% of population) in St. Vincent and the Grenadines in 2003 to that in 2005?
Ensure brevity in your answer.  0.76. What is the ratio of the Unemployed and educated male labor force (% of population) in Europe(all income levels) in 2003 to that in 2006?
Offer a very short reply. 1.01. What is the ratio of the Unemployed and educated male labor force (% of population) in Norway in 2003 to that in 2006?
Offer a very short reply. 1.31. What is the ratio of the Unemployed and educated male labor force (% of population) in St. Vincent and the Grenadines in 2003 to that in 2006?
Make the answer very short. 0.57. What is the ratio of the Unemployed and educated male labor force (% of population) in Thailand in 2003 to that in 2006?
Offer a very short reply. 1.13. What is the ratio of the Unemployed and educated male labor force (% of population) of Europe(all income levels) in 2003 to that in 2007?
Ensure brevity in your answer.  1.02. What is the ratio of the Unemployed and educated male labor force (% of population) of Norway in 2003 to that in 2007?
Keep it short and to the point. 1.57. What is the ratio of the Unemployed and educated male labor force (% of population) of St. Vincent and the Grenadines in 2003 to that in 2007?
Give a very brief answer. 0.5. What is the ratio of the Unemployed and educated male labor force (% of population) in Thailand in 2003 to that in 2007?
Keep it short and to the point. 0.96. What is the ratio of the Unemployed and educated male labor force (% of population) in Europe(all income levels) in 2003 to that in 2008?
Make the answer very short. 1.06. What is the ratio of the Unemployed and educated male labor force (% of population) in Norway in 2003 to that in 2008?
Ensure brevity in your answer.  1.56. What is the ratio of the Unemployed and educated male labor force (% of population) of St. Vincent and the Grenadines in 2003 to that in 2008?
Offer a terse response. 0.59. What is the ratio of the Unemployed and educated male labor force (% of population) in Thailand in 2003 to that in 2008?
Give a very brief answer. 2.32. What is the ratio of the Unemployed and educated male labor force (% of population) in Europe(all income levels) in 2003 to that in 2009?
Provide a short and direct response. 1.06. What is the ratio of the Unemployed and educated male labor force (% of population) in Norway in 2003 to that in 2009?
Offer a very short reply. 1.29. What is the ratio of the Unemployed and educated male labor force (% of population) of St. Vincent and the Grenadines in 2003 to that in 2009?
Offer a very short reply. 0.88. What is the ratio of the Unemployed and educated male labor force (% of population) of Thailand in 2003 to that in 2009?
Provide a short and direct response. 2.43. What is the ratio of the Unemployed and educated male labor force (% of population) in Norway in 2004 to that in 2005?
Provide a short and direct response. 1. What is the ratio of the Unemployed and educated male labor force (% of population) in St. Vincent and the Grenadines in 2004 to that in 2005?
Your answer should be compact. 0.79. What is the ratio of the Unemployed and educated male labor force (% of population) in Thailand in 2004 to that in 2005?
Provide a short and direct response. 1.08. What is the ratio of the Unemployed and educated male labor force (% of population) in Europe(all income levels) in 2004 to that in 2006?
Make the answer very short. 1.01. What is the ratio of the Unemployed and educated male labor force (% of population) in Norway in 2004 to that in 2006?
Offer a terse response. 1.5. What is the ratio of the Unemployed and educated male labor force (% of population) in St. Vincent and the Grenadines in 2004 to that in 2006?
Your response must be concise. 0.59. What is the ratio of the Unemployed and educated male labor force (% of population) in Thailand in 2004 to that in 2006?
Offer a terse response. 1.19. What is the ratio of the Unemployed and educated male labor force (% of population) of Europe(all income levels) in 2004 to that in 2007?
Provide a succinct answer. 1.03. What is the ratio of the Unemployed and educated male labor force (% of population) in Norway in 2004 to that in 2007?
Ensure brevity in your answer.  1.81. What is the ratio of the Unemployed and educated male labor force (% of population) of St. Vincent and the Grenadines in 2004 to that in 2007?
Your answer should be very brief. 0.52. What is the ratio of the Unemployed and educated male labor force (% of population) in Thailand in 2004 to that in 2007?
Ensure brevity in your answer.  1.01. What is the ratio of the Unemployed and educated male labor force (% of population) of Europe(all income levels) in 2004 to that in 2008?
Offer a very short reply. 1.07. What is the ratio of the Unemployed and educated male labor force (% of population) of Norway in 2004 to that in 2008?
Provide a short and direct response. 1.8. What is the ratio of the Unemployed and educated male labor force (% of population) in St. Vincent and the Grenadines in 2004 to that in 2008?
Provide a succinct answer. 0.62. What is the ratio of the Unemployed and educated male labor force (% of population) in Thailand in 2004 to that in 2008?
Offer a terse response. 2.46. What is the ratio of the Unemployed and educated male labor force (% of population) of Europe(all income levels) in 2004 to that in 2009?
Offer a terse response. 1.06. What is the ratio of the Unemployed and educated male labor force (% of population) of Norway in 2004 to that in 2009?
Ensure brevity in your answer.  1.49. What is the ratio of the Unemployed and educated male labor force (% of population) of St. Vincent and the Grenadines in 2004 to that in 2009?
Your answer should be very brief. 0.91. What is the ratio of the Unemployed and educated male labor force (% of population) of Thailand in 2004 to that in 2009?
Make the answer very short. 2.57. What is the ratio of the Unemployed and educated male labor force (% of population) of Europe(all income levels) in 2005 to that in 2006?
Offer a terse response. 1. What is the ratio of the Unemployed and educated male labor force (% of population) in Norway in 2005 to that in 2006?
Make the answer very short. 1.5. What is the ratio of the Unemployed and educated male labor force (% of population) in St. Vincent and the Grenadines in 2005 to that in 2006?
Keep it short and to the point. 0.76. What is the ratio of the Unemployed and educated male labor force (% of population) of Thailand in 2005 to that in 2006?
Provide a short and direct response. 1.11. What is the ratio of the Unemployed and educated male labor force (% of population) of Europe(all income levels) in 2005 to that in 2007?
Your response must be concise. 1.02. What is the ratio of the Unemployed and educated male labor force (% of population) of Norway in 2005 to that in 2007?
Ensure brevity in your answer.  1.81. What is the ratio of the Unemployed and educated male labor force (% of population) in St. Vincent and the Grenadines in 2005 to that in 2007?
Provide a short and direct response. 0.66. What is the ratio of the Unemployed and educated male labor force (% of population) in Thailand in 2005 to that in 2007?
Your response must be concise. 0.94. What is the ratio of the Unemployed and educated male labor force (% of population) in Europe(all income levels) in 2005 to that in 2008?
Provide a succinct answer. 1.06. What is the ratio of the Unemployed and educated male labor force (% of population) of Norway in 2005 to that in 2008?
Ensure brevity in your answer.  1.8. What is the ratio of the Unemployed and educated male labor force (% of population) of St. Vincent and the Grenadines in 2005 to that in 2008?
Keep it short and to the point. 0.79. What is the ratio of the Unemployed and educated male labor force (% of population) of Thailand in 2005 to that in 2008?
Provide a succinct answer. 2.28. What is the ratio of the Unemployed and educated male labor force (% of population) in Europe(all income levels) in 2005 to that in 2009?
Provide a succinct answer. 1.06. What is the ratio of the Unemployed and educated male labor force (% of population) in Norway in 2005 to that in 2009?
Your answer should be very brief. 1.49. What is the ratio of the Unemployed and educated male labor force (% of population) of St. Vincent and the Grenadines in 2005 to that in 2009?
Ensure brevity in your answer.  1.16. What is the ratio of the Unemployed and educated male labor force (% of population) of Thailand in 2005 to that in 2009?
Keep it short and to the point. 2.39. What is the ratio of the Unemployed and educated male labor force (% of population) of Europe(all income levels) in 2006 to that in 2007?
Offer a terse response. 1.02. What is the ratio of the Unemployed and educated male labor force (% of population) in Norway in 2006 to that in 2007?
Your answer should be compact. 1.21. What is the ratio of the Unemployed and educated male labor force (% of population) of St. Vincent and the Grenadines in 2006 to that in 2007?
Ensure brevity in your answer.  0.88. What is the ratio of the Unemployed and educated male labor force (% of population) of Thailand in 2006 to that in 2007?
Make the answer very short. 0.85. What is the ratio of the Unemployed and educated male labor force (% of population) in Europe(all income levels) in 2006 to that in 2008?
Make the answer very short. 1.06. What is the ratio of the Unemployed and educated male labor force (% of population) in Norway in 2006 to that in 2008?
Offer a very short reply. 1.19. What is the ratio of the Unemployed and educated male labor force (% of population) in St. Vincent and the Grenadines in 2006 to that in 2008?
Provide a short and direct response. 1.04. What is the ratio of the Unemployed and educated male labor force (% of population) in Thailand in 2006 to that in 2008?
Keep it short and to the point. 2.06. What is the ratio of the Unemployed and educated male labor force (% of population) in Europe(all income levels) in 2006 to that in 2009?
Provide a short and direct response. 1.05. What is the ratio of the Unemployed and educated male labor force (% of population) in St. Vincent and the Grenadines in 2006 to that in 2009?
Provide a short and direct response. 1.54. What is the ratio of the Unemployed and educated male labor force (% of population) in Thailand in 2006 to that in 2009?
Provide a short and direct response. 2.15. What is the ratio of the Unemployed and educated male labor force (% of population) in Europe(all income levels) in 2007 to that in 2008?
Your answer should be very brief. 1.04. What is the ratio of the Unemployed and educated male labor force (% of population) in Norway in 2007 to that in 2008?
Offer a very short reply. 0.99. What is the ratio of the Unemployed and educated male labor force (% of population) in St. Vincent and the Grenadines in 2007 to that in 2008?
Your answer should be very brief. 1.19. What is the ratio of the Unemployed and educated male labor force (% of population) of Thailand in 2007 to that in 2008?
Offer a terse response. 2.42. What is the ratio of the Unemployed and educated male labor force (% of population) in Europe(all income levels) in 2007 to that in 2009?
Give a very brief answer. 1.03. What is the ratio of the Unemployed and educated male labor force (% of population) in Norway in 2007 to that in 2009?
Provide a succinct answer. 0.82. What is the ratio of the Unemployed and educated male labor force (% of population) of St. Vincent and the Grenadines in 2007 to that in 2009?
Ensure brevity in your answer.  1.75. What is the ratio of the Unemployed and educated male labor force (% of population) of Thailand in 2007 to that in 2009?
Your answer should be compact. 2.53. What is the ratio of the Unemployed and educated male labor force (% of population) of Norway in 2008 to that in 2009?
Your answer should be compact. 0.83. What is the ratio of the Unemployed and educated male labor force (% of population) of St. Vincent and the Grenadines in 2008 to that in 2009?
Keep it short and to the point. 1.47. What is the ratio of the Unemployed and educated male labor force (% of population) of Thailand in 2008 to that in 2009?
Make the answer very short. 1.05. What is the difference between the highest and the second highest Unemployed and educated male labor force (% of population) in Europe(all income levels)?
Your answer should be compact. 0.11. What is the difference between the highest and the second highest Unemployed and educated male labor force (% of population) in St. Vincent and the Grenadines?
Offer a very short reply. 8.9. What is the difference between the highest and the second highest Unemployed and educated male labor force (% of population) in Thailand?
Provide a short and direct response. 0.6. What is the difference between the highest and the lowest Unemployed and educated male labor force (% of population) of Europe(all income levels)?
Make the answer very short. 3.12. What is the difference between the highest and the lowest Unemployed and educated male labor force (% of population) of Norway?
Provide a succinct answer. 24.5. What is the difference between the highest and the lowest Unemployed and educated male labor force (% of population) of St. Vincent and the Grenadines?
Offer a very short reply. 35.7. What is the difference between the highest and the lowest Unemployed and educated male labor force (% of population) in Thailand?
Offer a very short reply. 27. 